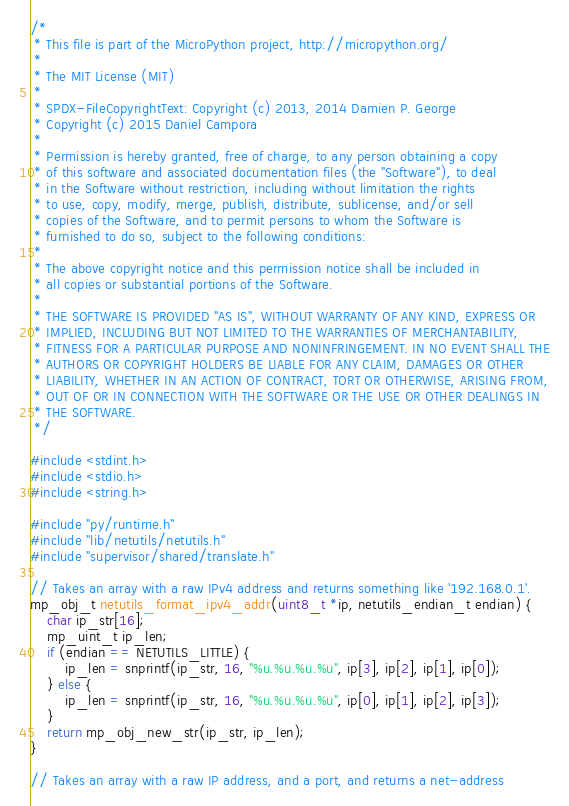Convert code to text. <code><loc_0><loc_0><loc_500><loc_500><_C_>/*
 * This file is part of the MicroPython project, http://micropython.org/
 *
 * The MIT License (MIT)
 *
 * SPDX-FileCopyrightText: Copyright (c) 2013, 2014 Damien P. George
 * Copyright (c) 2015 Daniel Campora
 *
 * Permission is hereby granted, free of charge, to any person obtaining a copy
 * of this software and associated documentation files (the "Software"), to deal
 * in the Software without restriction, including without limitation the rights
 * to use, copy, modify, merge, publish, distribute, sublicense, and/or sell
 * copies of the Software, and to permit persons to whom the Software is
 * furnished to do so, subject to the following conditions:
 *
 * The above copyright notice and this permission notice shall be included in
 * all copies or substantial portions of the Software.
 *
 * THE SOFTWARE IS PROVIDED "AS IS", WITHOUT WARRANTY OF ANY KIND, EXPRESS OR
 * IMPLIED, INCLUDING BUT NOT LIMITED TO THE WARRANTIES OF MERCHANTABILITY,
 * FITNESS FOR A PARTICULAR PURPOSE AND NONINFRINGEMENT. IN NO EVENT SHALL THE
 * AUTHORS OR COPYRIGHT HOLDERS BE LIABLE FOR ANY CLAIM, DAMAGES OR OTHER
 * LIABILITY, WHETHER IN AN ACTION OF CONTRACT, TORT OR OTHERWISE, ARISING FROM,
 * OUT OF OR IN CONNECTION WITH THE SOFTWARE OR THE USE OR OTHER DEALINGS IN
 * THE SOFTWARE.
 */

#include <stdint.h>
#include <stdio.h>
#include <string.h>

#include "py/runtime.h"
#include "lib/netutils/netutils.h"
#include "supervisor/shared/translate.h"

// Takes an array with a raw IPv4 address and returns something like '192.168.0.1'.
mp_obj_t netutils_format_ipv4_addr(uint8_t *ip, netutils_endian_t endian) {
    char ip_str[16];
    mp_uint_t ip_len;
    if (endian == NETUTILS_LITTLE) {
        ip_len = snprintf(ip_str, 16, "%u.%u.%u.%u", ip[3], ip[2], ip[1], ip[0]);
    } else {
        ip_len = snprintf(ip_str, 16, "%u.%u.%u.%u", ip[0], ip[1], ip[2], ip[3]);
    }
    return mp_obj_new_str(ip_str, ip_len);
}

// Takes an array with a raw IP address, and a port, and returns a net-address</code> 